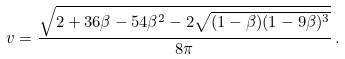Convert formula to latex. <formula><loc_0><loc_0><loc_500><loc_500>v = \frac { \sqrt { 2 + 3 6 \beta - 5 4 \beta ^ { 2 } - 2 \sqrt { ( 1 - \beta ) ( 1 - 9 \beta ) ^ { 3 } } } } { 8 \pi } \, .</formula> 